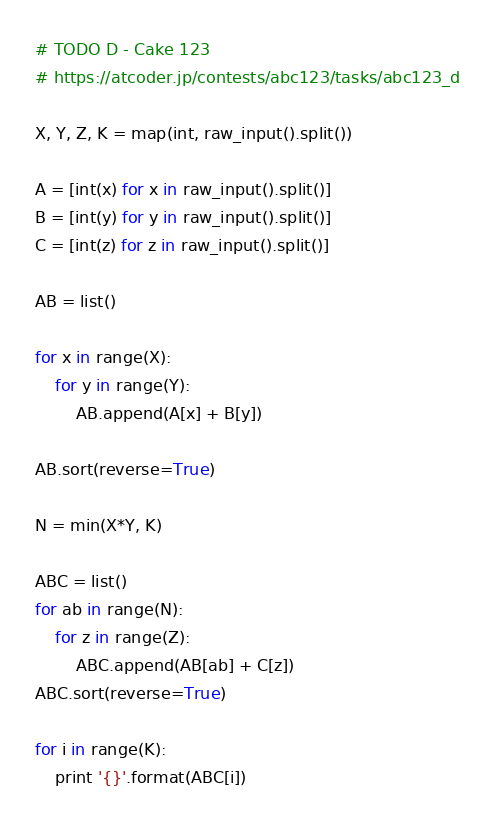Convert code to text. <code><loc_0><loc_0><loc_500><loc_500><_Python_># TODO D - Cake 123
# https://atcoder.jp/contests/abc123/tasks/abc123_d

X, Y, Z, K = map(int, raw_input().split())

A = [int(x) for x in raw_input().split()]
B = [int(y) for y in raw_input().split()]
C = [int(z) for z in raw_input().split()]

AB = list()

for x in range(X):
    for y in range(Y):
        AB.append(A[x] + B[y])

AB.sort(reverse=True)

N = min(X*Y, K)

ABC = list()
for ab in range(N):
    for z in range(Z):
        ABC.append(AB[ab] + C[z])
ABC.sort(reverse=True)

for i in range(K):
    print '{}'.format(ABC[i])
</code> 